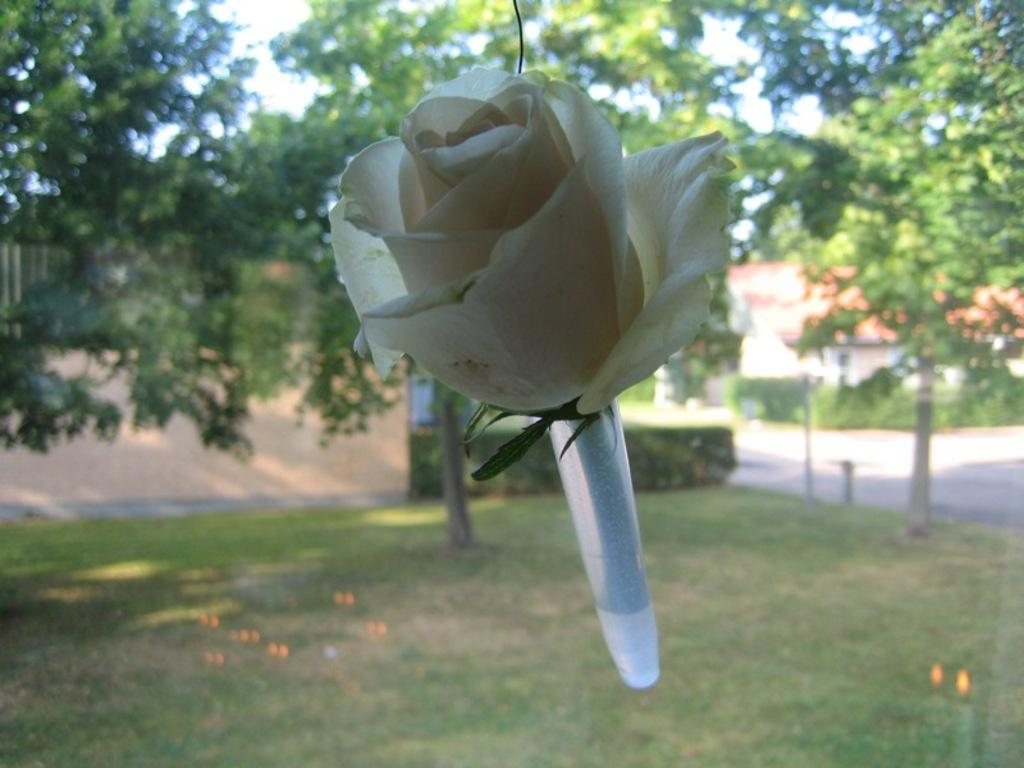What type of flower is in the image? There is a white flower in the image. What can be seen in the background of the image? There are trees, a house, and grass in the background of the image. What holiday is being celebrated in the image? There is no indication of a holiday being celebrated in the image. 